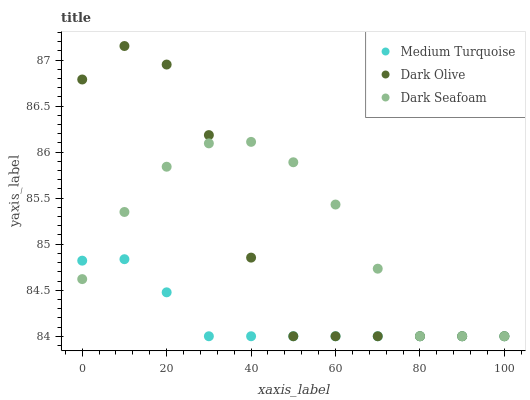Does Medium Turquoise have the minimum area under the curve?
Answer yes or no. Yes. Does Dark Seafoam have the maximum area under the curve?
Answer yes or no. Yes. Does Dark Olive have the minimum area under the curve?
Answer yes or no. No. Does Dark Olive have the maximum area under the curve?
Answer yes or no. No. Is Medium Turquoise the smoothest?
Answer yes or no. Yes. Is Dark Olive the roughest?
Answer yes or no. Yes. Is Dark Olive the smoothest?
Answer yes or no. No. Is Medium Turquoise the roughest?
Answer yes or no. No. Does Dark Seafoam have the lowest value?
Answer yes or no. Yes. Does Dark Olive have the highest value?
Answer yes or no. Yes. Does Medium Turquoise have the highest value?
Answer yes or no. No. Does Medium Turquoise intersect Dark Olive?
Answer yes or no. Yes. Is Medium Turquoise less than Dark Olive?
Answer yes or no. No. Is Medium Turquoise greater than Dark Olive?
Answer yes or no. No. 